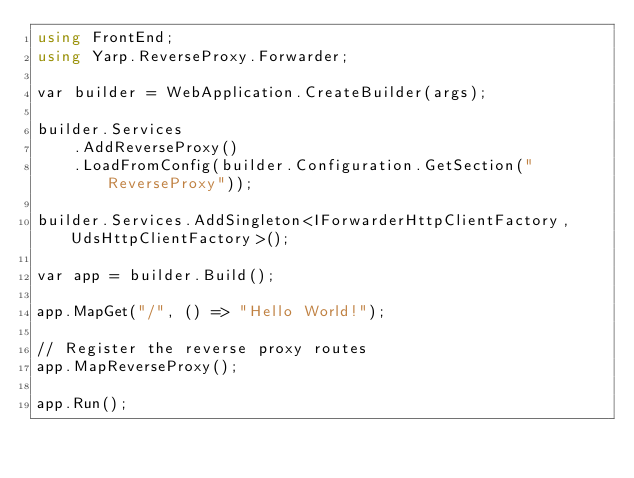<code> <loc_0><loc_0><loc_500><loc_500><_C#_>using FrontEnd;
using Yarp.ReverseProxy.Forwarder;

var builder = WebApplication.CreateBuilder(args);

builder.Services
    .AddReverseProxy()
    .LoadFromConfig(builder.Configuration.GetSection("ReverseProxy"));

builder.Services.AddSingleton<IForwarderHttpClientFactory, UdsHttpClientFactory>();

var app = builder.Build();

app.MapGet("/", () => "Hello World!");

// Register the reverse proxy routes
app.MapReverseProxy();

app.Run();
</code> 